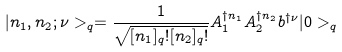Convert formula to latex. <formula><loc_0><loc_0><loc_500><loc_500>| n _ { 1 } , n _ { 2 } ; \nu > _ { q } = \frac { 1 } { \sqrt { [ n _ { 1 } ] _ { q } ! [ n _ { 2 } ] _ { q } ! } } A _ { 1 } ^ { \dagger n _ { 1 } } A _ { 2 } ^ { \dagger n _ { 2 } } b ^ { \dagger \nu } | 0 > _ { q }</formula> 